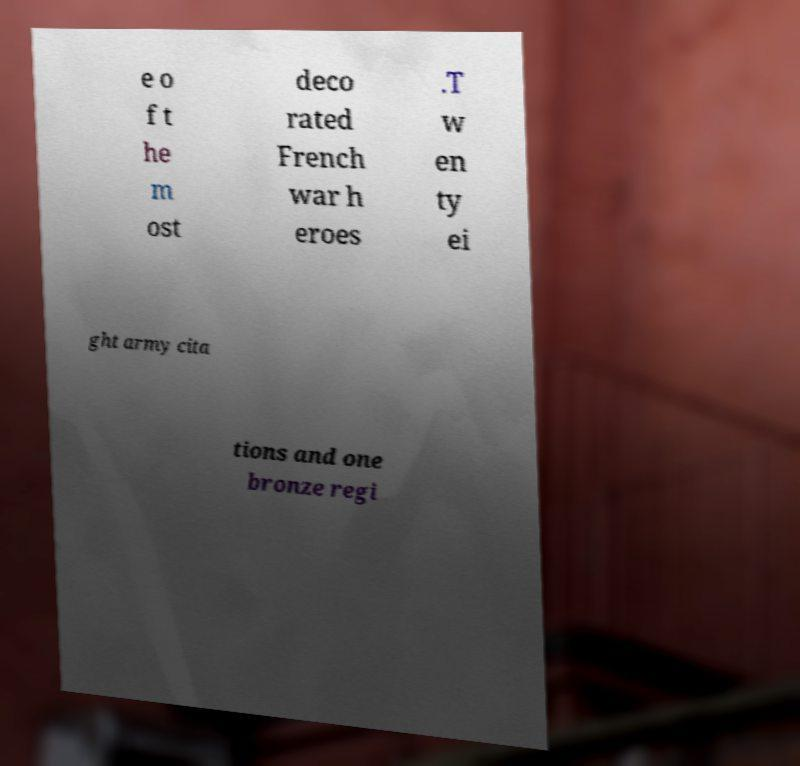Can you accurately transcribe the text from the provided image for me? e o f t he m ost deco rated French war h eroes .T w en ty ei ght army cita tions and one bronze regi 